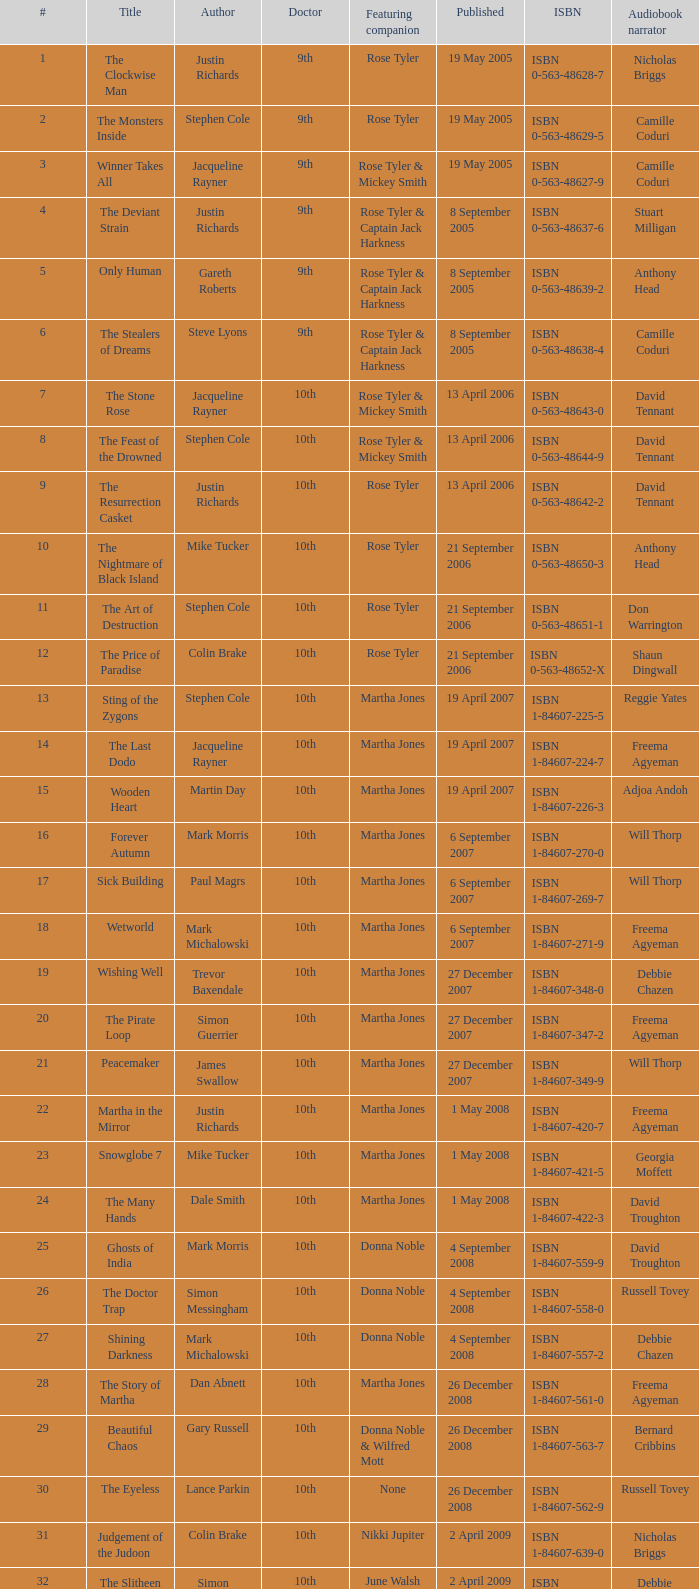Who are the highlighted associates of number 3? Rose Tyler & Mickey Smith. 